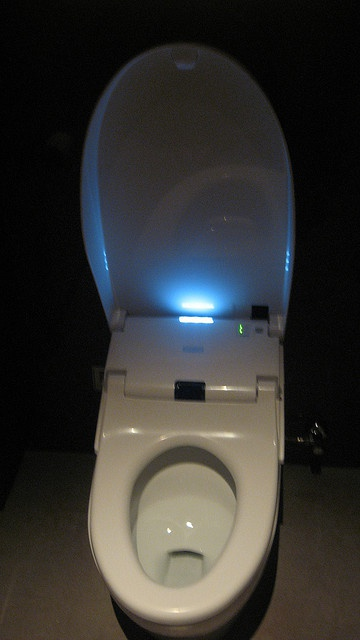Describe the objects in this image and their specific colors. I can see a toilet in black, gray, and tan tones in this image. 